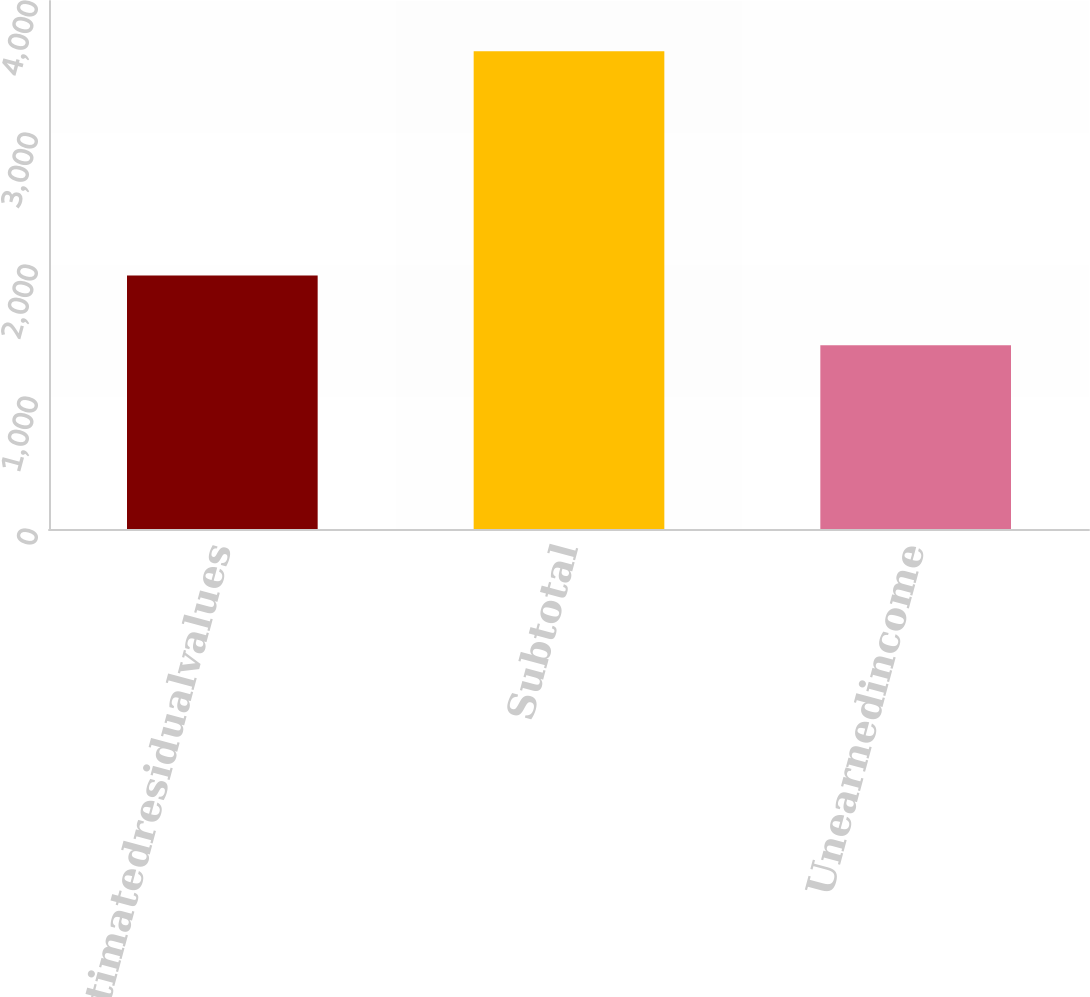<chart> <loc_0><loc_0><loc_500><loc_500><bar_chart><fcel>Estimatedresidualvalues<fcel>Subtotal<fcel>Unearnedincome<nl><fcel>1921<fcel>3619<fcel>1392<nl></chart> 